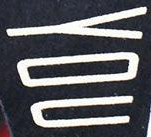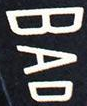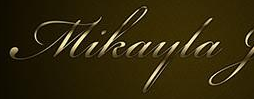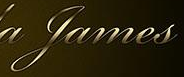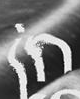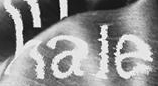What words are shown in these images in order, separated by a semicolon? YOU; BAD; Mikayla; James; in; hale 